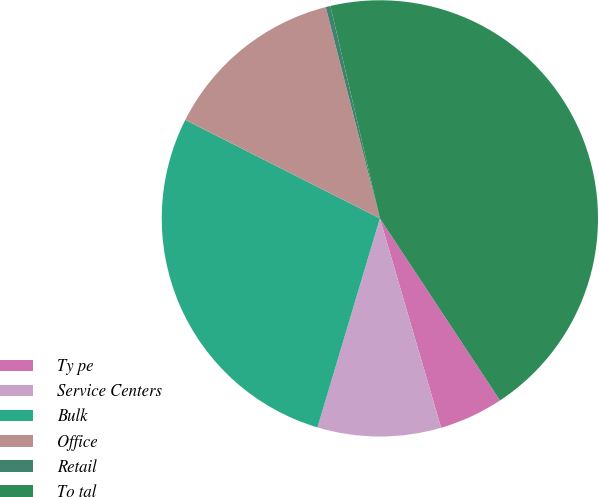Convert chart to OTSL. <chart><loc_0><loc_0><loc_500><loc_500><pie_chart><fcel>Ty pe<fcel>Service Centers<fcel>Bulk<fcel>Office<fcel>Retail<fcel>To tal<nl><fcel>4.75%<fcel>9.15%<fcel>27.83%<fcel>13.55%<fcel>0.35%<fcel>44.35%<nl></chart> 